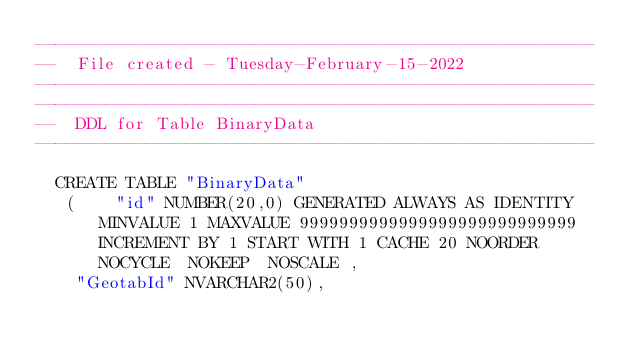<code> <loc_0><loc_0><loc_500><loc_500><_SQL_>--------------------------------------------------------
--  File created - Tuesday-February-15-2022   
--------------------------------------------------------
--------------------------------------------------------
--  DDL for Table BinaryData
--------------------------------------------------------

  CREATE TABLE "BinaryData" 
   (	"id" NUMBER(20,0) GENERATED ALWAYS AS IDENTITY MINVALUE 1 MAXVALUE 9999999999999999999999999999 INCREMENT BY 1 START WITH 1 CACHE 20 NOORDER  NOCYCLE  NOKEEP  NOSCALE , 
	"GeotabId" NVARCHAR2(50), </code> 